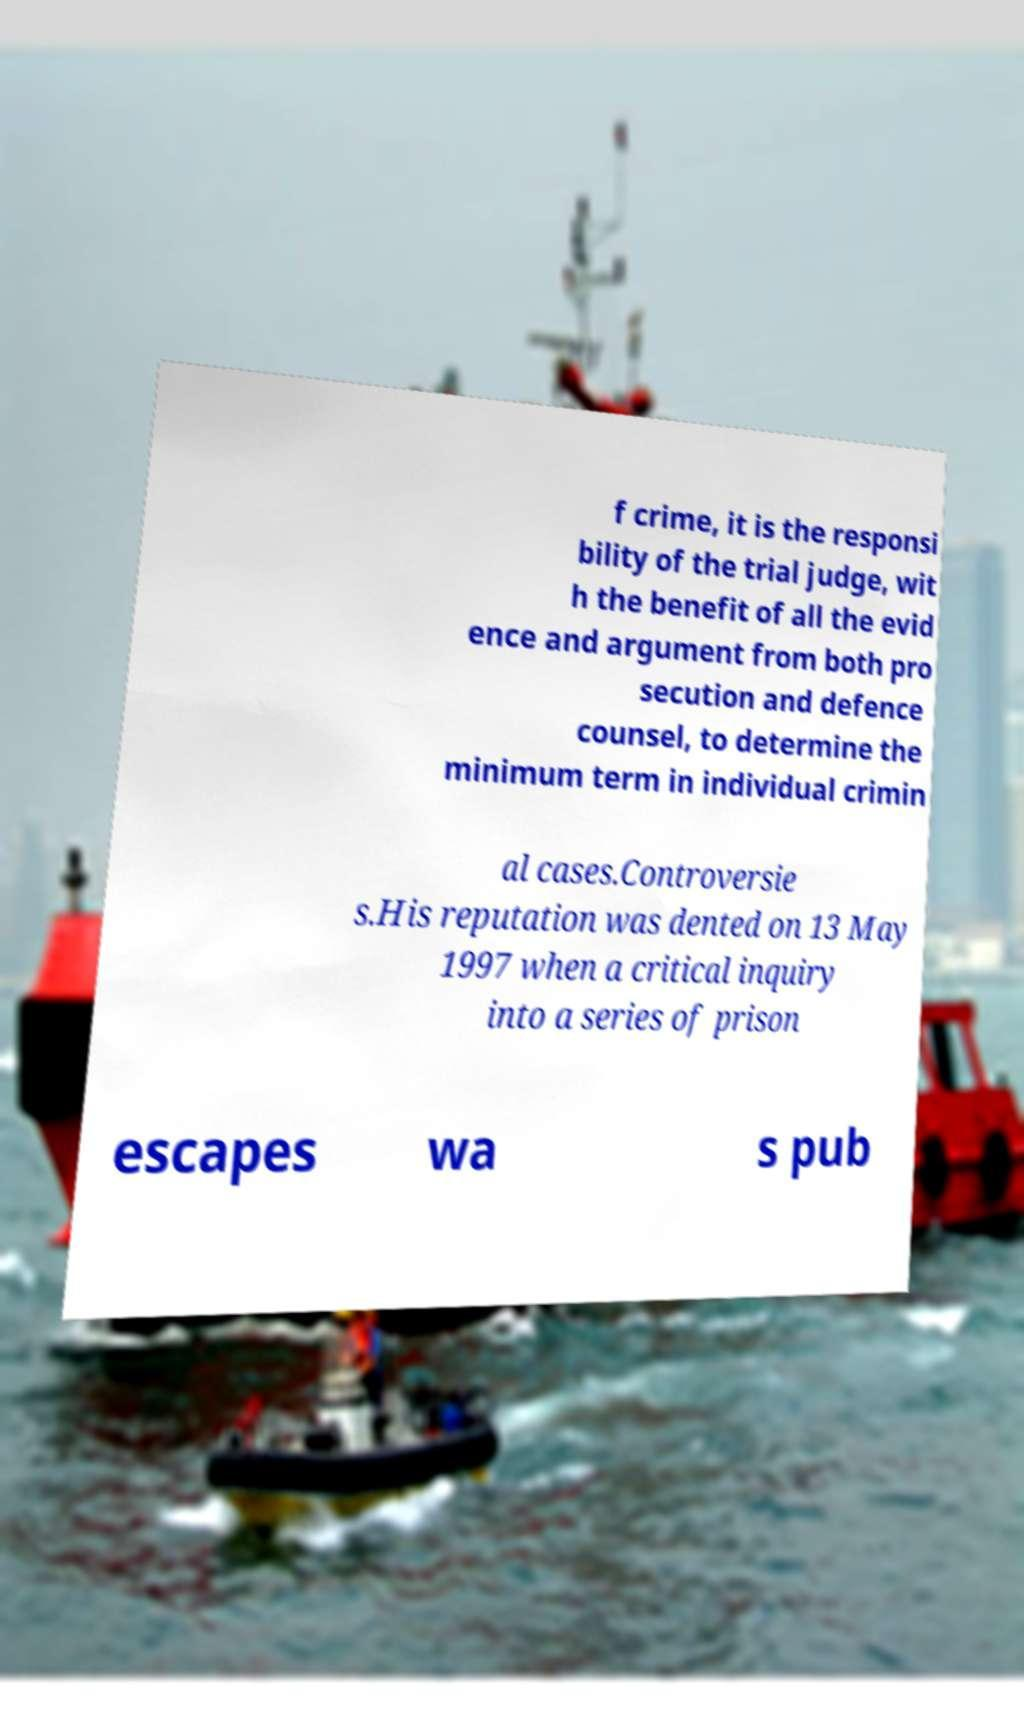Please identify and transcribe the text found in this image. f crime, it is the responsi bility of the trial judge, wit h the benefit of all the evid ence and argument from both pro secution and defence counsel, to determine the minimum term in individual crimin al cases.Controversie s.His reputation was dented on 13 May 1997 when a critical inquiry into a series of prison escapes wa s pub 